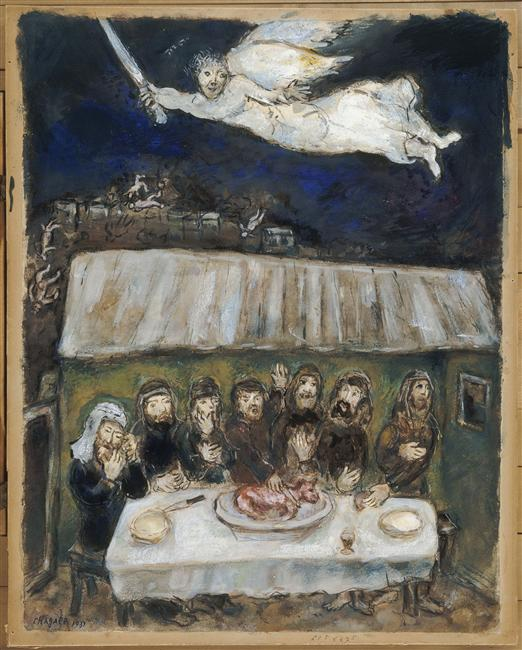What might the sword held by the angelic figure symbolize in this context? The sword in the angel's hands could symbolize justice or divine intervention, suggesting a moment of moral reckoning or protection. It might also represent the cutting of ties or the severance of past actions, signifying a moment of pivotal change or enlightenment for the figures gathered below. 